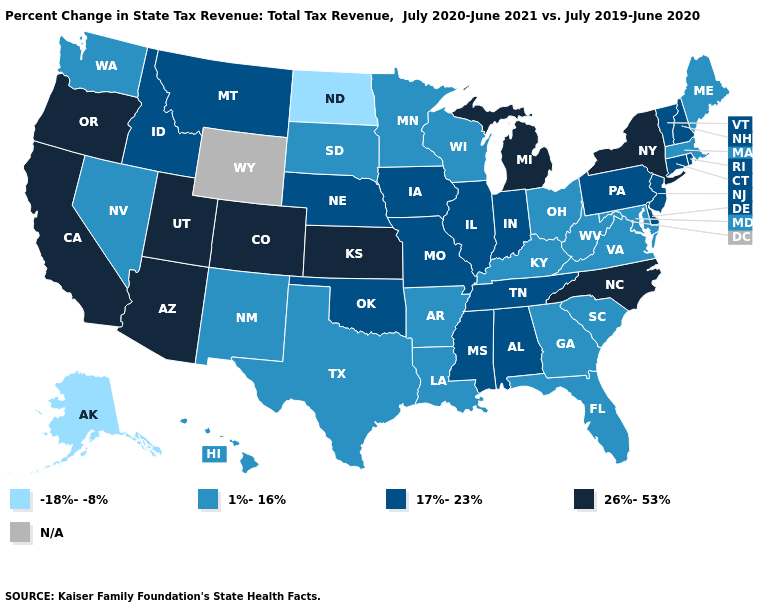What is the value of Nevada?
Be succinct. 1%-16%. What is the highest value in states that border Montana?
Short answer required. 17%-23%. Does North Dakota have the highest value in the USA?
Short answer required. No. What is the highest value in states that border Kansas?
Write a very short answer. 26%-53%. Does Maine have the highest value in the Northeast?
Concise answer only. No. How many symbols are there in the legend?
Concise answer only. 5. Among the states that border South Dakota , which have the highest value?
Give a very brief answer. Iowa, Montana, Nebraska. What is the value of Oklahoma?
Keep it brief. 17%-23%. Among the states that border North Carolina , which have the highest value?
Keep it brief. Tennessee. Name the states that have a value in the range 17%-23%?
Be succinct. Alabama, Connecticut, Delaware, Idaho, Illinois, Indiana, Iowa, Mississippi, Missouri, Montana, Nebraska, New Hampshire, New Jersey, Oklahoma, Pennsylvania, Rhode Island, Tennessee, Vermont. Name the states that have a value in the range 1%-16%?
Give a very brief answer. Arkansas, Florida, Georgia, Hawaii, Kentucky, Louisiana, Maine, Maryland, Massachusetts, Minnesota, Nevada, New Mexico, Ohio, South Carolina, South Dakota, Texas, Virginia, Washington, West Virginia, Wisconsin. What is the value of Connecticut?
Short answer required. 17%-23%. What is the value of Arizona?
Keep it brief. 26%-53%. Name the states that have a value in the range 1%-16%?
Concise answer only. Arkansas, Florida, Georgia, Hawaii, Kentucky, Louisiana, Maine, Maryland, Massachusetts, Minnesota, Nevada, New Mexico, Ohio, South Carolina, South Dakota, Texas, Virginia, Washington, West Virginia, Wisconsin. 